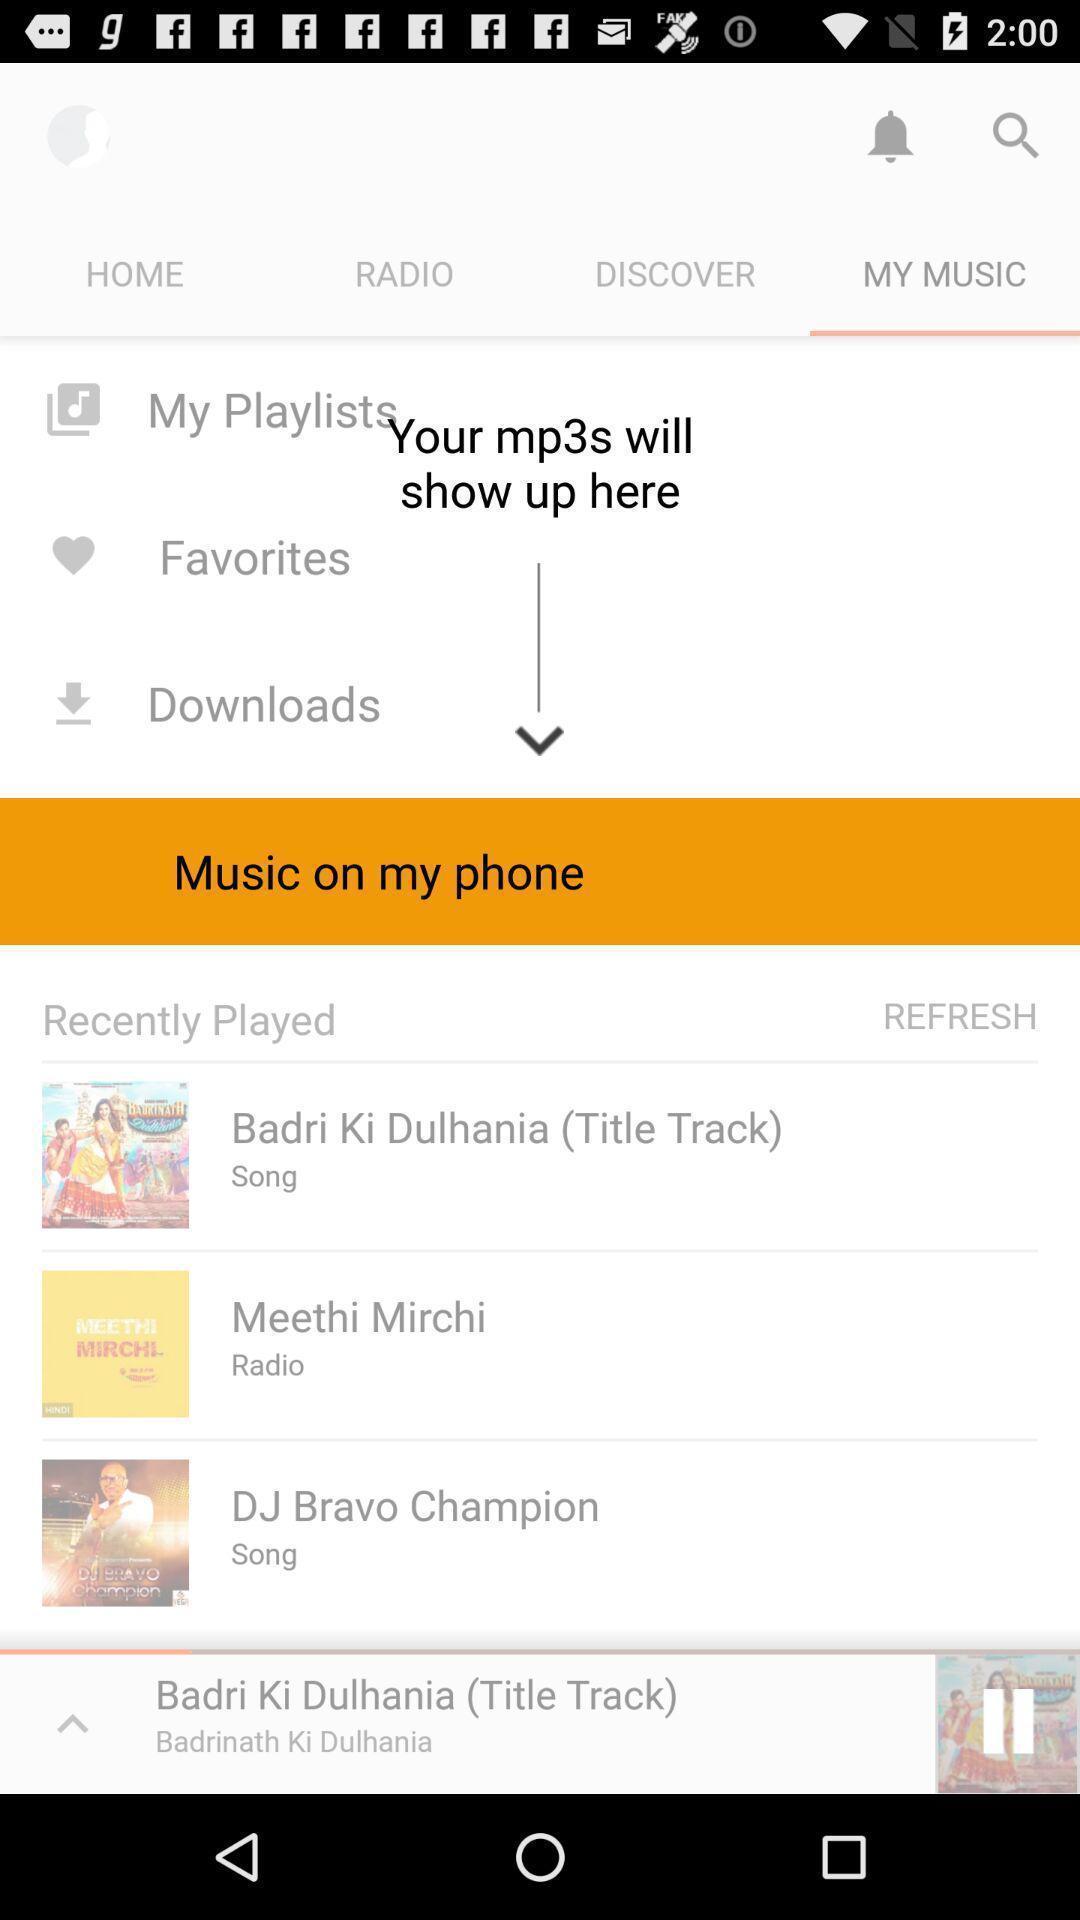Give me a narrative description of this picture. Pop up message of music on my phone. 